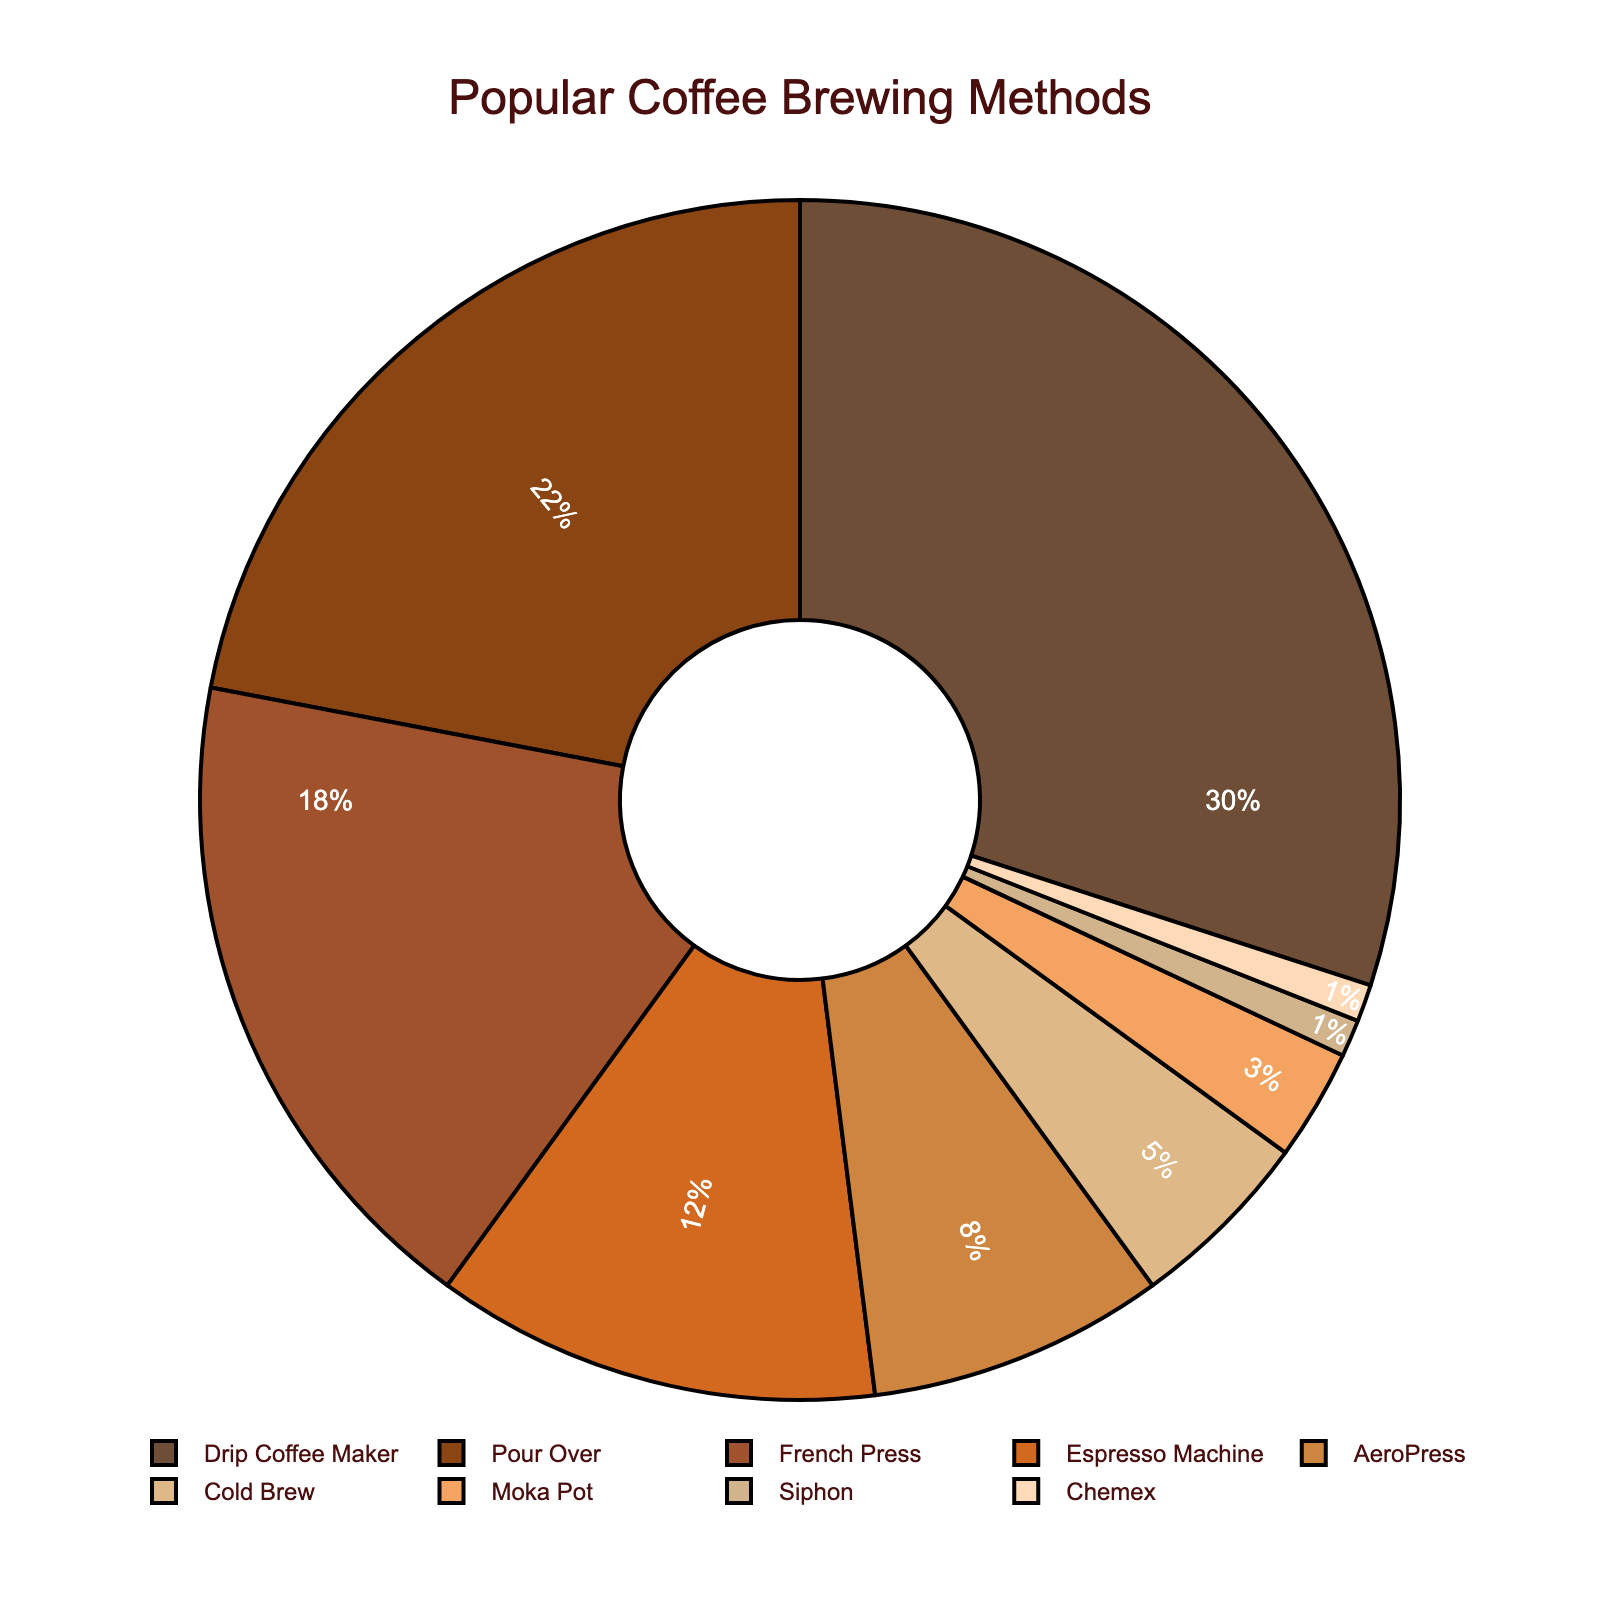What is the most popular brewing method? The most immediate and clear segment, representing 30% of the chart, is labeled "Drip Coffee Maker." This suggests it is the most popular method.
Answer: Drip Coffee Maker Which brewing method has a percentage twice that of AeroPress? AeroPress holds 8% of the total. Multiplying 8% by 2 gives 16%, which is closest to the percentage of French Press, which is 18%.
Answer: French Press Which brewing methods combined make up less than 10% of the total? The methods with percentages under 10% are AeroPress (8%), Cold Brew (5%), Moka Pot (3%), Siphon (1%), and Chemex (1%). Summing these gives 18%, but individually, only Siphon, Chemex, and Moka Pot combined (1% + 1% + 3% = 5%) stay under 10%.
Answer: Siphon, Chemex, and Moka Pot How many brewing methods have a percentage of 10% or more? From the chart, Drip Coffee Maker (30%), Pour Over (22%), French Press (18%), and Espresso Machine (12%) all have percentages of 10% or higher. This totals up to four methods.
Answer: Four What is the percentage difference between the most popular and the least popular brewing methods? Drip Coffee Maker is the most popular at 30%, and both Siphon and Chemex are the least popular at 1% each. The difference is 30% - 1% = 29%.
Answer: 29% Is the combined percentage of Pour Over and Espresso Machine greater than that of Drip Coffee Maker alone? Pour Over has 22% and Espresso Machine has 12%. Together, they account for 22% + 12% = 34%, whereas Drip Coffee Maker alone accounts for 30%. Therefore, 34% is greater than 30%.
Answer: Yes Which brewing method is closest in popularity to the combination of Siphon and Chemex? Siphon and Chemex each have 1%, summing them gives 2%. The method closest to 2% on the chart with the next lowest percentages is the Moka Pot at 3%.
Answer: Moka Pot What is the visual color of the least popular brewing methods? The two least popular methods, Siphon and Chemex, are visually represented in light colors; specifically, shades of light tan and peach respectively.
Answer: Light tan and peach If you add the percentages for Pour Over, French Press, and Espresso Machine, what percentage of the total does this represent? The percentages for Pour Over (22%), French Press (18%), and Espresso Machine (12%) sum to 22% + 18% + 12% = 52%.
Answer: 52% What percentage of the total is made up by the brewing methods with less than 5% each? The methods with less than 5% are Moka Pot (3%), Siphon (1%), and Chemex (1%), summing these gives 3% + 1% + 1% = 5%.
Answer: 5% 